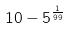Convert formula to latex. <formula><loc_0><loc_0><loc_500><loc_500>1 0 - 5 ^ { \frac { 1 } { 9 9 } }</formula> 